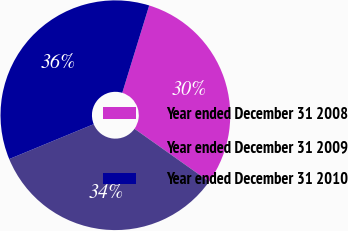<chart> <loc_0><loc_0><loc_500><loc_500><pie_chart><fcel>Year ended December 31 2008<fcel>Year ended December 31 2009<fcel>Year ended December 31 2010<nl><fcel>30.05%<fcel>33.96%<fcel>35.99%<nl></chart> 